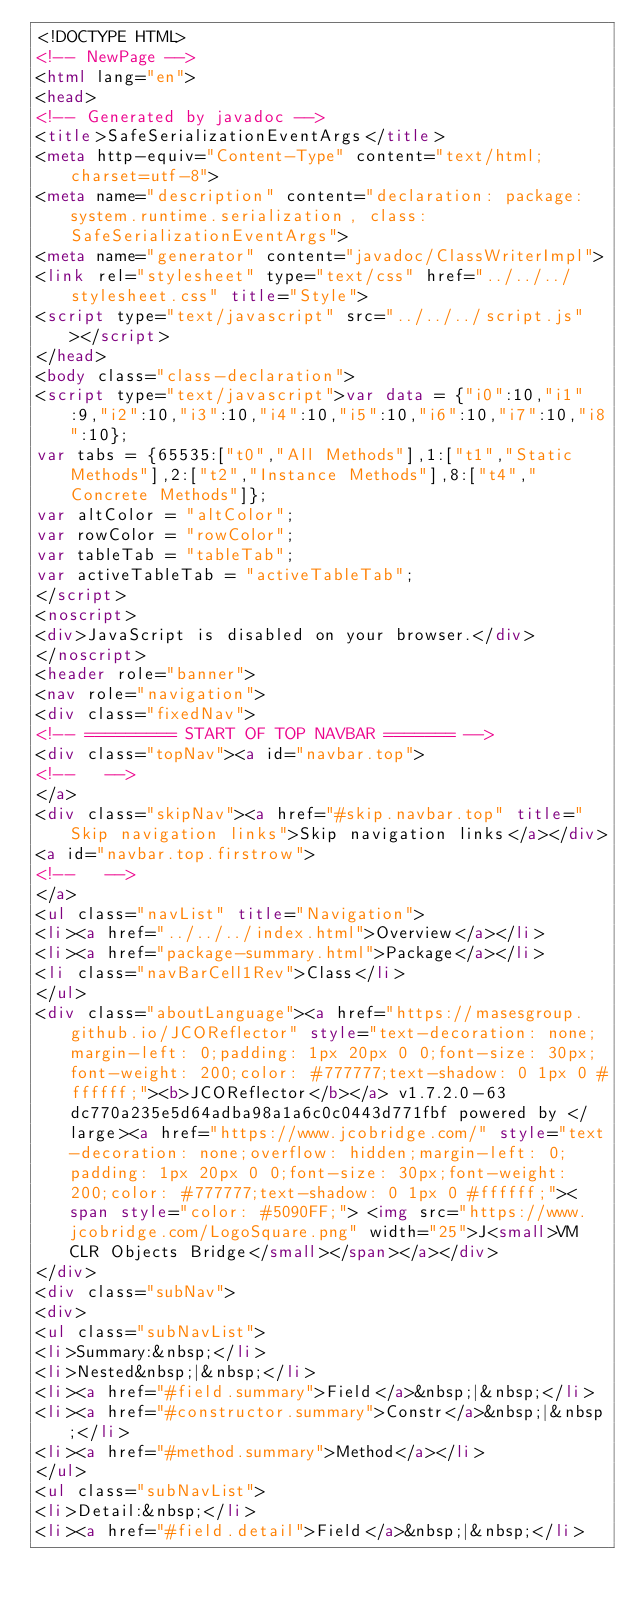<code> <loc_0><loc_0><loc_500><loc_500><_HTML_><!DOCTYPE HTML>
<!-- NewPage -->
<html lang="en">
<head>
<!-- Generated by javadoc -->
<title>SafeSerializationEventArgs</title>
<meta http-equiv="Content-Type" content="text/html; charset=utf-8">
<meta name="description" content="declaration: package: system.runtime.serialization, class: SafeSerializationEventArgs">
<meta name="generator" content="javadoc/ClassWriterImpl">
<link rel="stylesheet" type="text/css" href="../../../stylesheet.css" title="Style">
<script type="text/javascript" src="../../../script.js"></script>
</head>
<body class="class-declaration">
<script type="text/javascript">var data = {"i0":10,"i1":9,"i2":10,"i3":10,"i4":10,"i5":10,"i6":10,"i7":10,"i8":10};
var tabs = {65535:["t0","All Methods"],1:["t1","Static Methods"],2:["t2","Instance Methods"],8:["t4","Concrete Methods"]};
var altColor = "altColor";
var rowColor = "rowColor";
var tableTab = "tableTab";
var activeTableTab = "activeTableTab";
</script>
<noscript>
<div>JavaScript is disabled on your browser.</div>
</noscript>
<header role="banner">
<nav role="navigation">
<div class="fixedNav">
<!-- ========= START OF TOP NAVBAR ======= -->
<div class="topNav"><a id="navbar.top">
<!--   -->
</a>
<div class="skipNav"><a href="#skip.navbar.top" title="Skip navigation links">Skip navigation links</a></div>
<a id="navbar.top.firstrow">
<!--   -->
</a>
<ul class="navList" title="Navigation">
<li><a href="../../../index.html">Overview</a></li>
<li><a href="package-summary.html">Package</a></li>
<li class="navBarCell1Rev">Class</li>
</ul>
<div class="aboutLanguage"><a href="https://masesgroup.github.io/JCOReflector" style="text-decoration: none;margin-left: 0;padding: 1px 20px 0 0;font-size: 30px;font-weight: 200;color: #777777;text-shadow: 0 1px 0 #ffffff;"><b>JCOReflector</b></a> v1.7.2.0-63dc770a235e5d64adba98a1a6c0c0443d771fbf powered by </large><a href="https://www.jcobridge.com/" style="text-decoration: none;overflow: hidden;margin-left: 0;padding: 1px 20px 0 0;font-size: 30px;font-weight: 200;color: #777777;text-shadow: 0 1px 0 #ffffff;"><span style="color: #5090FF;"> <img src="https://www.jcobridge.com/LogoSquare.png" width="25">J<small>VM CLR Objects Bridge</small></span></a></div>
</div>
<div class="subNav">
<div>
<ul class="subNavList">
<li>Summary:&nbsp;</li>
<li>Nested&nbsp;|&nbsp;</li>
<li><a href="#field.summary">Field</a>&nbsp;|&nbsp;</li>
<li><a href="#constructor.summary">Constr</a>&nbsp;|&nbsp;</li>
<li><a href="#method.summary">Method</a></li>
</ul>
<ul class="subNavList">
<li>Detail:&nbsp;</li>
<li><a href="#field.detail">Field</a>&nbsp;|&nbsp;</li></code> 